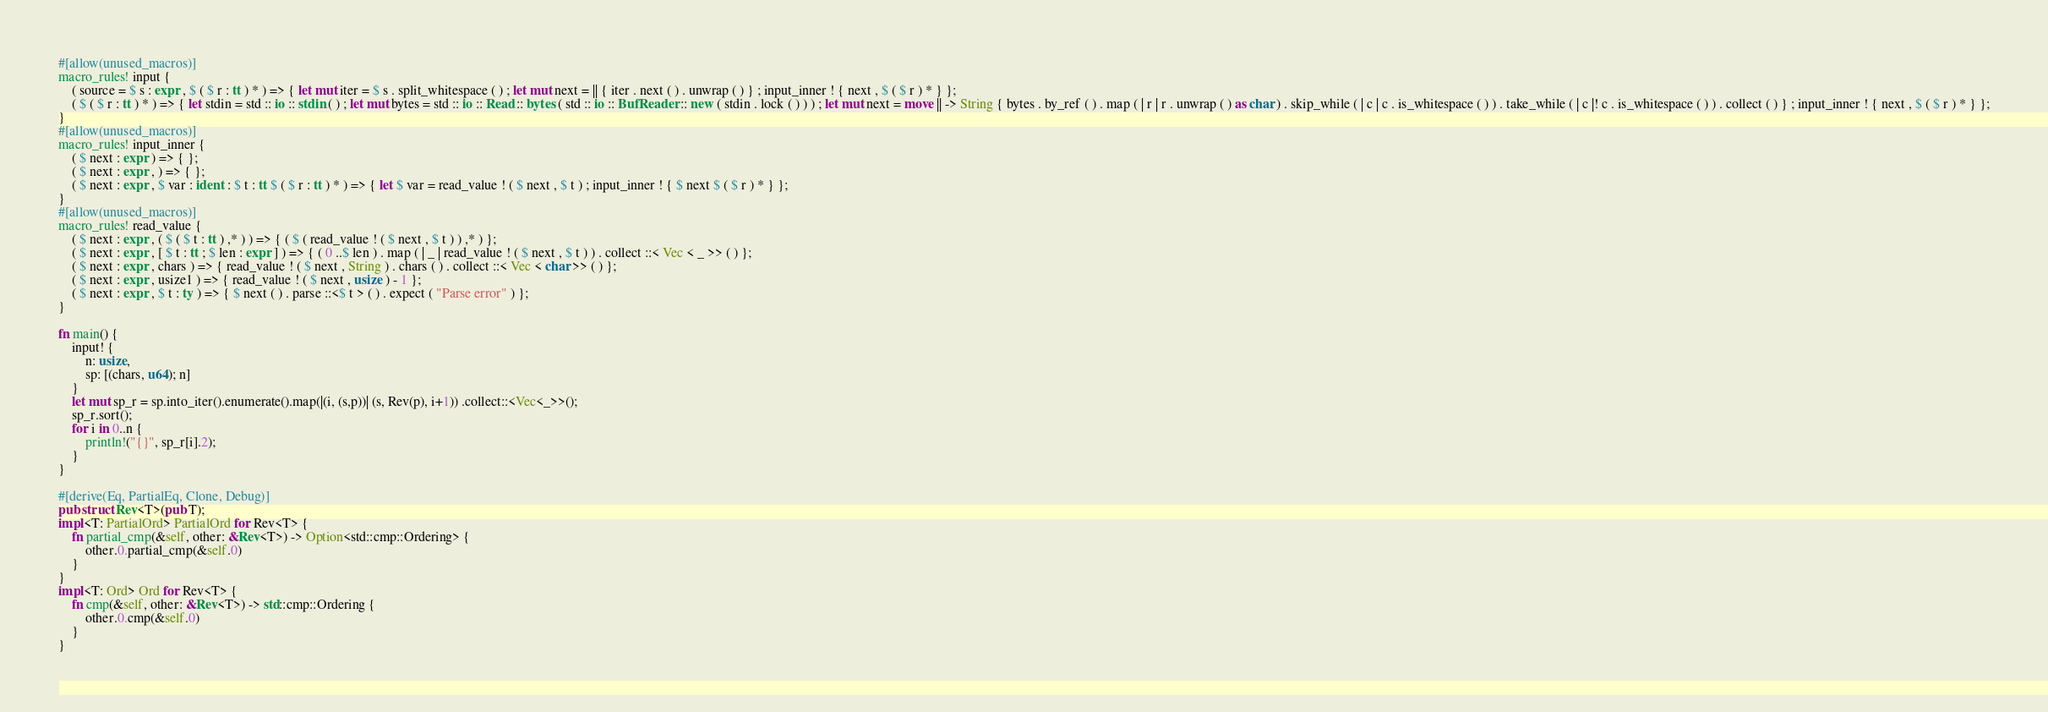Convert code to text. <code><loc_0><loc_0><loc_500><loc_500><_Rust_>#[allow(unused_macros)]
macro_rules! input {
    ( source = $ s : expr , $ ( $ r : tt ) * ) => { let mut iter = $ s . split_whitespace ( ) ; let mut next = || { iter . next ( ) . unwrap ( ) } ; input_inner ! { next , $ ( $ r ) * } };
    ( $ ( $ r : tt ) * ) => { let stdin = std :: io :: stdin ( ) ; let mut bytes = std :: io :: Read :: bytes ( std :: io :: BufReader :: new ( stdin . lock ( ) ) ) ; let mut next = move || -> String { bytes . by_ref ( ) . map ( | r | r . unwrap ( ) as char ) . skip_while ( | c | c . is_whitespace ( ) ) . take_while ( | c |! c . is_whitespace ( ) ) . collect ( ) } ; input_inner ! { next , $ ( $ r ) * } };
}
#[allow(unused_macros)]
macro_rules! input_inner {
    ( $ next : expr ) => { };
    ( $ next : expr , ) => { };
    ( $ next : expr , $ var : ident : $ t : tt $ ( $ r : tt ) * ) => { let $ var = read_value ! ( $ next , $ t ) ; input_inner ! { $ next $ ( $ r ) * } };
}
#[allow(unused_macros)]
macro_rules! read_value {
    ( $ next : expr , ( $ ( $ t : tt ) ,* ) ) => { ( $ ( read_value ! ( $ next , $ t ) ) ,* ) };
    ( $ next : expr , [ $ t : tt ; $ len : expr ] ) => { ( 0 ..$ len ) . map ( | _ | read_value ! ( $ next , $ t ) ) . collect ::< Vec < _ >> ( ) };
    ( $ next : expr , chars ) => { read_value ! ( $ next , String ) . chars ( ) . collect ::< Vec < char >> ( ) };
    ( $ next : expr , usize1 ) => { read_value ! ( $ next , usize ) - 1 };
    ( $ next : expr , $ t : ty ) => { $ next ( ) . parse ::<$ t > ( ) . expect ( "Parse error" ) };
}

fn main() {
    input! {
        n: usize,
        sp: [(chars, u64); n]
    }
    let mut sp_r = sp.into_iter().enumerate().map(|(i, (s,p))| (s, Rev(p), i+1)) .collect::<Vec<_>>();
    sp_r.sort();
    for i in 0..n {
        println!("{}", sp_r[i].2);
    }
}

#[derive(Eq, PartialEq, Clone, Debug)]
pub struct Rev<T>(pub T);
impl<T: PartialOrd> PartialOrd for Rev<T> {
    fn partial_cmp(&self, other: &Rev<T>) -> Option<std::cmp::Ordering> {
        other.0.partial_cmp(&self.0)
    }
}
impl<T: Ord> Ord for Rev<T> {
    fn cmp(&self, other: &Rev<T>) -> std::cmp::Ordering {
        other.0.cmp(&self.0)
    }
}</code> 